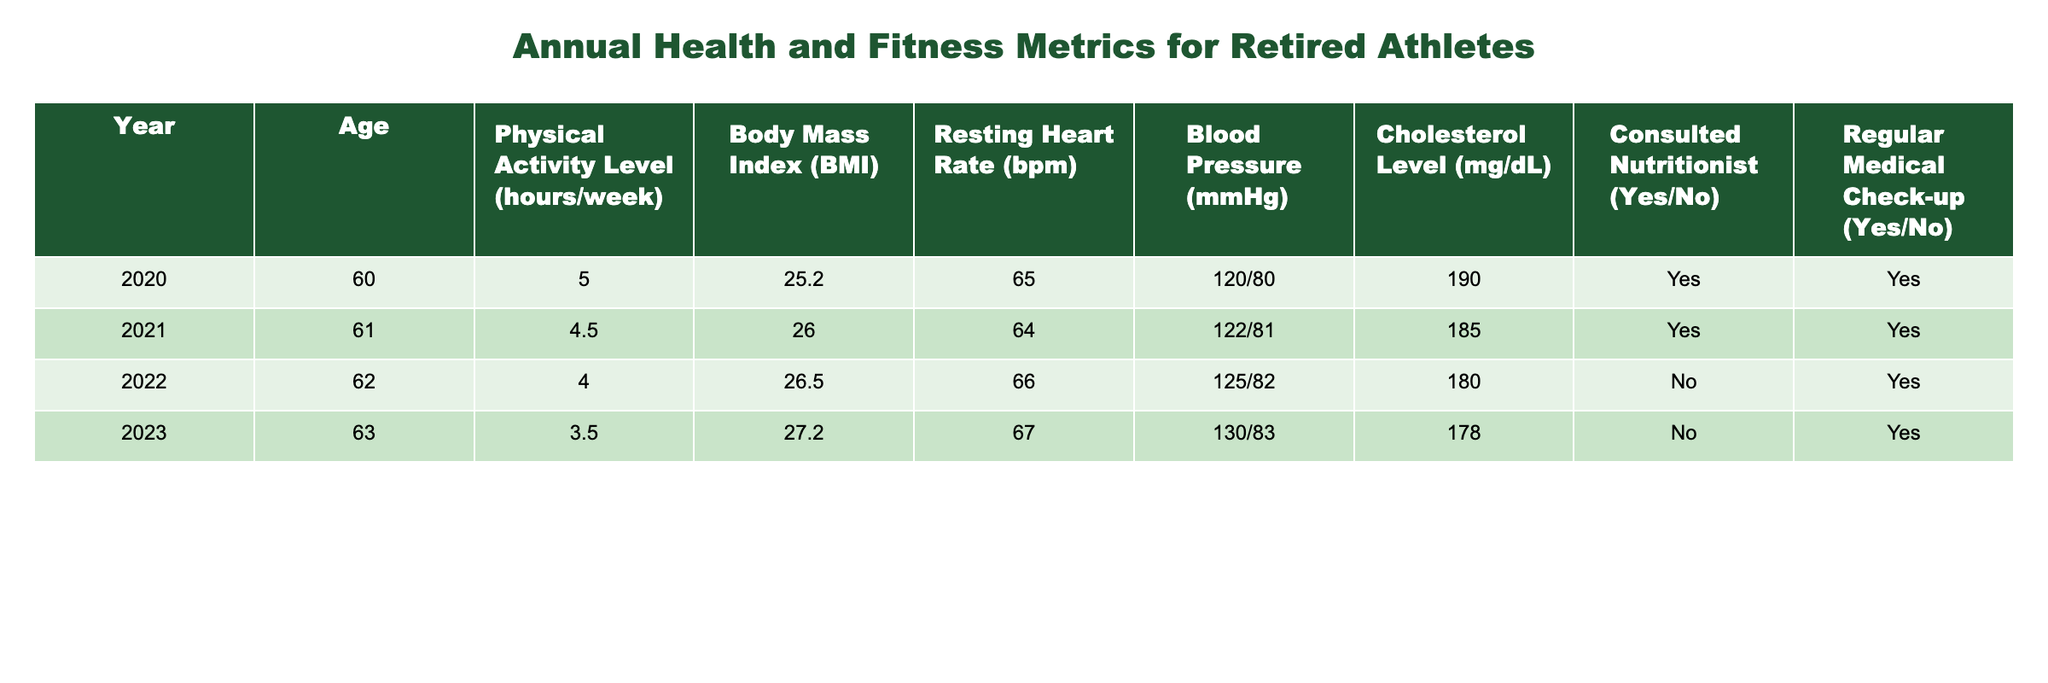What is the Physical Activity Level in 2022? The table shows the Physical Activity Level for each year. Looking at the row for 2022, the value is 4 hours/week.
Answer: 4 hours/week Which year had the highest Body Mass Index (BMI)? The table lists the BMI values for each year. By comparing these values, 2023 has the highest BMI of 27.2.
Answer: 2023 What is the average Resting Heart Rate (bpm) from 2020 to 2023? The Resting Heart Rate values are 65, 64, 66, and 67 bpm. To find the average, sum them: 65 + 64 + 66 + 67 = 262. Then divide by the number of years (4): 262/4 = 65.5.
Answer: 65.5 bpm Did the athlete consult a nutritionist in 2021? Referring to the 2021 row, it shows that the athlete did consult a nutritionist.
Answer: Yes In which year did the athlete have the lowest Physical Activity Level? By examining the Physical Activity Level values for each year, we see that 2023 has the lowest value at 3.5 hours/week.
Answer: 2023 Was the Blood Pressure measured higher in 2022 or 2023? The Blood Pressure values for these years are 125/82 for 2022 and 130/83 for 2023. Comparing these, 2023 has a higher Blood Pressure reading.
Answer: 2023 What percentage of years had Regular Medical Check-ups? The years with Regular Medical Check-ups are 2020, 2021, 2022, and 2023, which is 4 out of 4 years. To find the percentage, use (4/4) * 100 = 100%.
Answer: 100% What is the trend of Cholesterol Levels from 2020 to 2023? The Cholesterol Levels are 190, 185, 180, and 178 mg/dL for the respective years. Observing these values shows a decreasing trend over the years.
Answer: Decreasing trend Which year had the highest increase in age among the data points? The age increases consistently by 1 year each year: 60 in 2020, 61 in 2021, 62 in 2022, and 63 in 2023. Thus, the increase is equal each year by 1 year.
Answer: All years have the same increment 